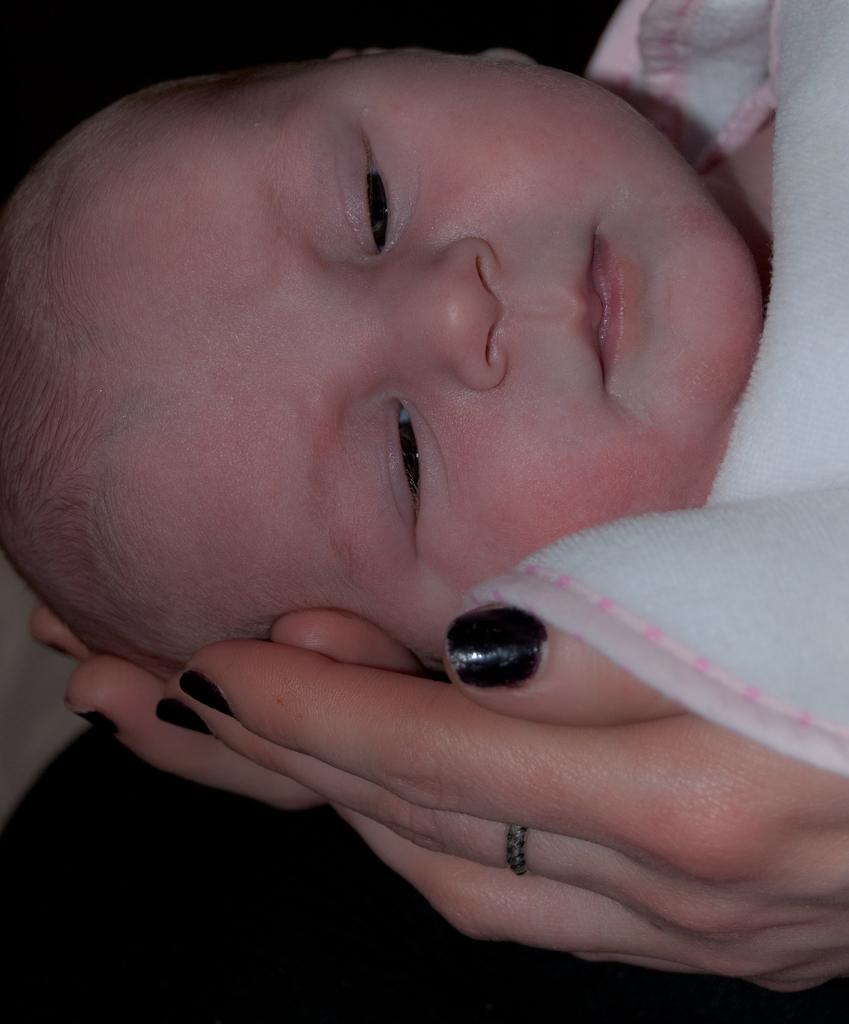Who is the main subject in the image? There is a woman in the image. What is the woman doing in the image? The woman is holding a baby with her hands. What type of lamp is hanging above the woman and baby in the image? There is no lamp present in the image; it only features the woman holding a baby. 